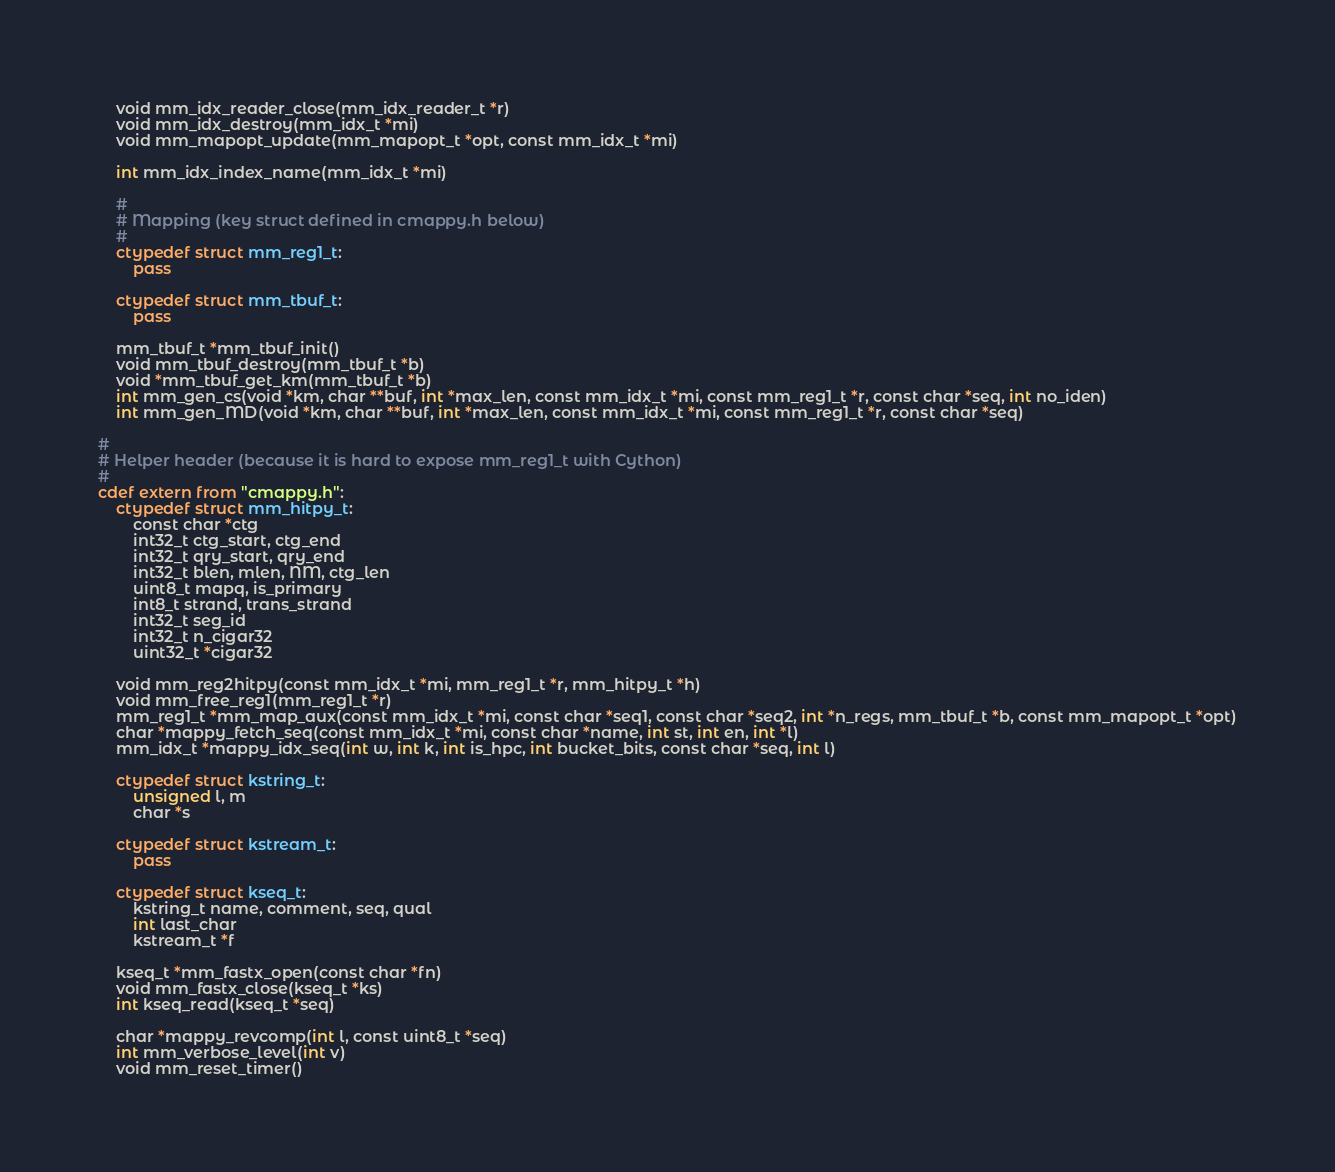Convert code to text. <code><loc_0><loc_0><loc_500><loc_500><_Cython_>	void mm_idx_reader_close(mm_idx_reader_t *r)
	void mm_idx_destroy(mm_idx_t *mi)
	void mm_mapopt_update(mm_mapopt_t *opt, const mm_idx_t *mi)

	int mm_idx_index_name(mm_idx_t *mi)

	#
	# Mapping (key struct defined in cmappy.h below)
	#
	ctypedef struct mm_reg1_t:
		pass

	ctypedef struct mm_tbuf_t:
		pass

	mm_tbuf_t *mm_tbuf_init()
	void mm_tbuf_destroy(mm_tbuf_t *b)
	void *mm_tbuf_get_km(mm_tbuf_t *b)
	int mm_gen_cs(void *km, char **buf, int *max_len, const mm_idx_t *mi, const mm_reg1_t *r, const char *seq, int no_iden)
	int mm_gen_MD(void *km, char **buf, int *max_len, const mm_idx_t *mi, const mm_reg1_t *r, const char *seq)

#
# Helper header (because it is hard to expose mm_reg1_t with Cython)
#
cdef extern from "cmappy.h":
	ctypedef struct mm_hitpy_t:
		const char *ctg
		int32_t ctg_start, ctg_end
		int32_t qry_start, qry_end
		int32_t blen, mlen, NM, ctg_len
		uint8_t mapq, is_primary
		int8_t strand, trans_strand
		int32_t seg_id
		int32_t n_cigar32
		uint32_t *cigar32

	void mm_reg2hitpy(const mm_idx_t *mi, mm_reg1_t *r, mm_hitpy_t *h)
	void mm_free_reg1(mm_reg1_t *r)
	mm_reg1_t *mm_map_aux(const mm_idx_t *mi, const char *seq1, const char *seq2, int *n_regs, mm_tbuf_t *b, const mm_mapopt_t *opt)
	char *mappy_fetch_seq(const mm_idx_t *mi, const char *name, int st, int en, int *l)
	mm_idx_t *mappy_idx_seq(int w, int k, int is_hpc, int bucket_bits, const char *seq, int l)

	ctypedef struct kstring_t:
		unsigned l, m
		char *s

	ctypedef struct kstream_t:
		pass

	ctypedef struct kseq_t:
		kstring_t name, comment, seq, qual
		int last_char
		kstream_t *f

	kseq_t *mm_fastx_open(const char *fn)
	void mm_fastx_close(kseq_t *ks)
	int kseq_read(kseq_t *seq)

	char *mappy_revcomp(int l, const uint8_t *seq)
	int mm_verbose_level(int v)
	void mm_reset_timer()
</code> 